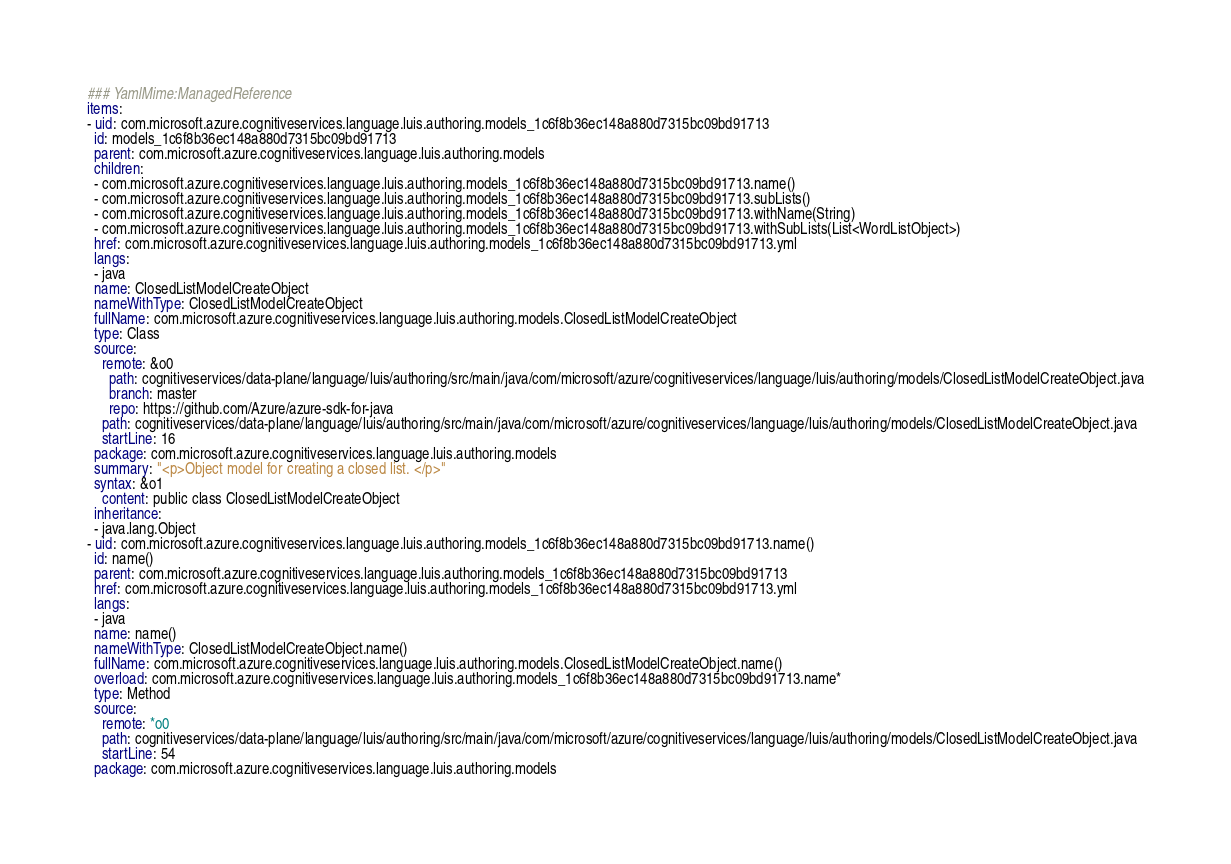Convert code to text. <code><loc_0><loc_0><loc_500><loc_500><_YAML_>### YamlMime:ManagedReference
items:
- uid: com.microsoft.azure.cognitiveservices.language.luis.authoring.models_1c6f8b36ec148a880d7315bc09bd91713
  id: models_1c6f8b36ec148a880d7315bc09bd91713
  parent: com.microsoft.azure.cognitiveservices.language.luis.authoring.models
  children:
  - com.microsoft.azure.cognitiveservices.language.luis.authoring.models_1c6f8b36ec148a880d7315bc09bd91713.name()
  - com.microsoft.azure.cognitiveservices.language.luis.authoring.models_1c6f8b36ec148a880d7315bc09bd91713.subLists()
  - com.microsoft.azure.cognitiveservices.language.luis.authoring.models_1c6f8b36ec148a880d7315bc09bd91713.withName(String)
  - com.microsoft.azure.cognitiveservices.language.luis.authoring.models_1c6f8b36ec148a880d7315bc09bd91713.withSubLists(List<WordListObject>)
  href: com.microsoft.azure.cognitiveservices.language.luis.authoring.models_1c6f8b36ec148a880d7315bc09bd91713.yml
  langs:
  - java
  name: ClosedListModelCreateObject
  nameWithType: ClosedListModelCreateObject
  fullName: com.microsoft.azure.cognitiveservices.language.luis.authoring.models.ClosedListModelCreateObject
  type: Class
  source:
    remote: &o0
      path: cognitiveservices/data-plane/language/luis/authoring/src/main/java/com/microsoft/azure/cognitiveservices/language/luis/authoring/models/ClosedListModelCreateObject.java
      branch: master
      repo: https://github.com/Azure/azure-sdk-for-java
    path: cognitiveservices/data-plane/language/luis/authoring/src/main/java/com/microsoft/azure/cognitiveservices/language/luis/authoring/models/ClosedListModelCreateObject.java
    startLine: 16
  package: com.microsoft.azure.cognitiveservices.language.luis.authoring.models
  summary: "<p>Object model for creating a closed list. </p>"
  syntax: &o1
    content: public class ClosedListModelCreateObject
  inheritance:
  - java.lang.Object
- uid: com.microsoft.azure.cognitiveservices.language.luis.authoring.models_1c6f8b36ec148a880d7315bc09bd91713.name()
  id: name()
  parent: com.microsoft.azure.cognitiveservices.language.luis.authoring.models_1c6f8b36ec148a880d7315bc09bd91713
  href: com.microsoft.azure.cognitiveservices.language.luis.authoring.models_1c6f8b36ec148a880d7315bc09bd91713.yml
  langs:
  - java
  name: name()
  nameWithType: ClosedListModelCreateObject.name()
  fullName: com.microsoft.azure.cognitiveservices.language.luis.authoring.models.ClosedListModelCreateObject.name()
  overload: com.microsoft.azure.cognitiveservices.language.luis.authoring.models_1c6f8b36ec148a880d7315bc09bd91713.name*
  type: Method
  source:
    remote: *o0
    path: cognitiveservices/data-plane/language/luis/authoring/src/main/java/com/microsoft/azure/cognitiveservices/language/luis/authoring/models/ClosedListModelCreateObject.java
    startLine: 54
  package: com.microsoft.azure.cognitiveservices.language.luis.authoring.models</code> 